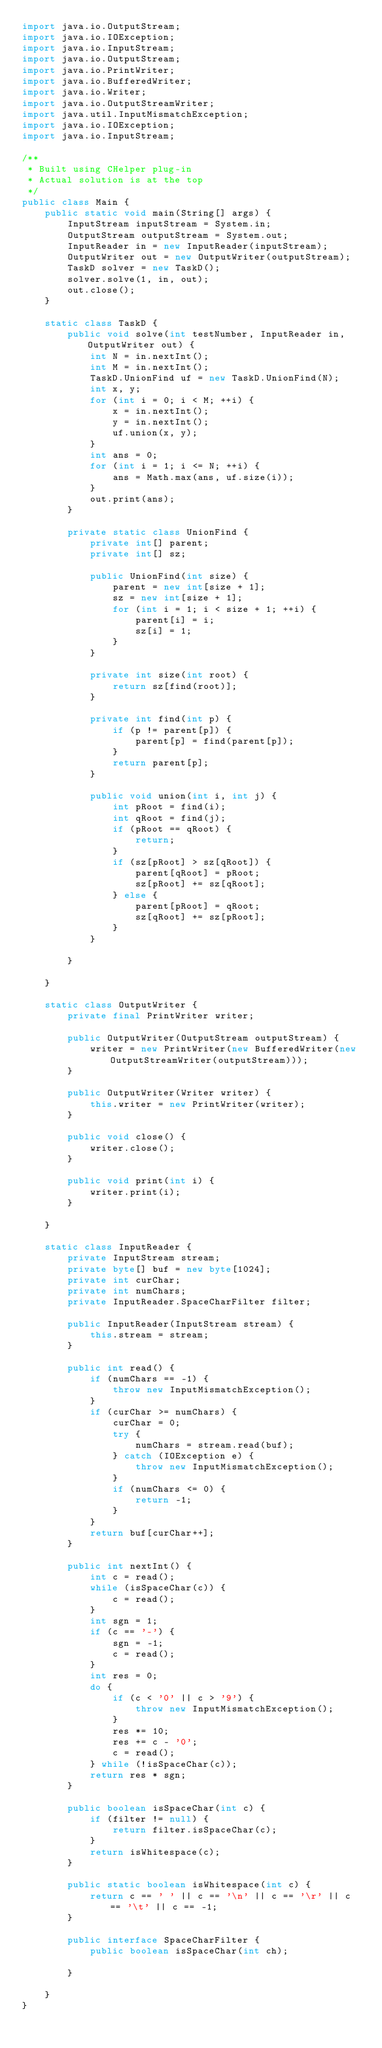Convert code to text. <code><loc_0><loc_0><loc_500><loc_500><_Java_>import java.io.OutputStream;
import java.io.IOException;
import java.io.InputStream;
import java.io.OutputStream;
import java.io.PrintWriter;
import java.io.BufferedWriter;
import java.io.Writer;
import java.io.OutputStreamWriter;
import java.util.InputMismatchException;
import java.io.IOException;
import java.io.InputStream;

/**
 * Built using CHelper plug-in
 * Actual solution is at the top
 */
public class Main {
    public static void main(String[] args) {
        InputStream inputStream = System.in;
        OutputStream outputStream = System.out;
        InputReader in = new InputReader(inputStream);
        OutputWriter out = new OutputWriter(outputStream);
        TaskD solver = new TaskD();
        solver.solve(1, in, out);
        out.close();
    }

    static class TaskD {
        public void solve(int testNumber, InputReader in, OutputWriter out) {
            int N = in.nextInt();
            int M = in.nextInt();
            TaskD.UnionFind uf = new TaskD.UnionFind(N);
            int x, y;
            for (int i = 0; i < M; ++i) {
                x = in.nextInt();
                y = in.nextInt();
                uf.union(x, y);
            }
            int ans = 0;
            for (int i = 1; i <= N; ++i) {
                ans = Math.max(ans, uf.size(i));
            }
            out.print(ans);
        }

        private static class UnionFind {
            private int[] parent;
            private int[] sz;

            public UnionFind(int size) {
                parent = new int[size + 1];
                sz = new int[size + 1];
                for (int i = 1; i < size + 1; ++i) {
                    parent[i] = i;
                    sz[i] = 1;
                }
            }

            private int size(int root) {
                return sz[find(root)];
            }

            private int find(int p) {
                if (p != parent[p]) {
                    parent[p] = find(parent[p]);
                }
                return parent[p];
            }

            public void union(int i, int j) {
                int pRoot = find(i);
                int qRoot = find(j);
                if (pRoot == qRoot) {
                    return;
                }
                if (sz[pRoot] > sz[qRoot]) {
                    parent[qRoot] = pRoot;
                    sz[pRoot] += sz[qRoot];
                } else {
                    parent[pRoot] = qRoot;
                    sz[qRoot] += sz[pRoot];
                }
            }

        }

    }

    static class OutputWriter {
        private final PrintWriter writer;

        public OutputWriter(OutputStream outputStream) {
            writer = new PrintWriter(new BufferedWriter(new OutputStreamWriter(outputStream)));
        }

        public OutputWriter(Writer writer) {
            this.writer = new PrintWriter(writer);
        }

        public void close() {
            writer.close();
        }

        public void print(int i) {
            writer.print(i);
        }

    }

    static class InputReader {
        private InputStream stream;
        private byte[] buf = new byte[1024];
        private int curChar;
        private int numChars;
        private InputReader.SpaceCharFilter filter;

        public InputReader(InputStream stream) {
            this.stream = stream;
        }

        public int read() {
            if (numChars == -1) {
                throw new InputMismatchException();
            }
            if (curChar >= numChars) {
                curChar = 0;
                try {
                    numChars = stream.read(buf);
                } catch (IOException e) {
                    throw new InputMismatchException();
                }
                if (numChars <= 0) {
                    return -1;
                }
            }
            return buf[curChar++];
        }

        public int nextInt() {
            int c = read();
            while (isSpaceChar(c)) {
                c = read();
            }
            int sgn = 1;
            if (c == '-') {
                sgn = -1;
                c = read();
            }
            int res = 0;
            do {
                if (c < '0' || c > '9') {
                    throw new InputMismatchException();
                }
                res *= 10;
                res += c - '0';
                c = read();
            } while (!isSpaceChar(c));
            return res * sgn;
        }

        public boolean isSpaceChar(int c) {
            if (filter != null) {
                return filter.isSpaceChar(c);
            }
            return isWhitespace(c);
        }

        public static boolean isWhitespace(int c) {
            return c == ' ' || c == '\n' || c == '\r' || c == '\t' || c == -1;
        }

        public interface SpaceCharFilter {
            public boolean isSpaceChar(int ch);

        }

    }
}

</code> 